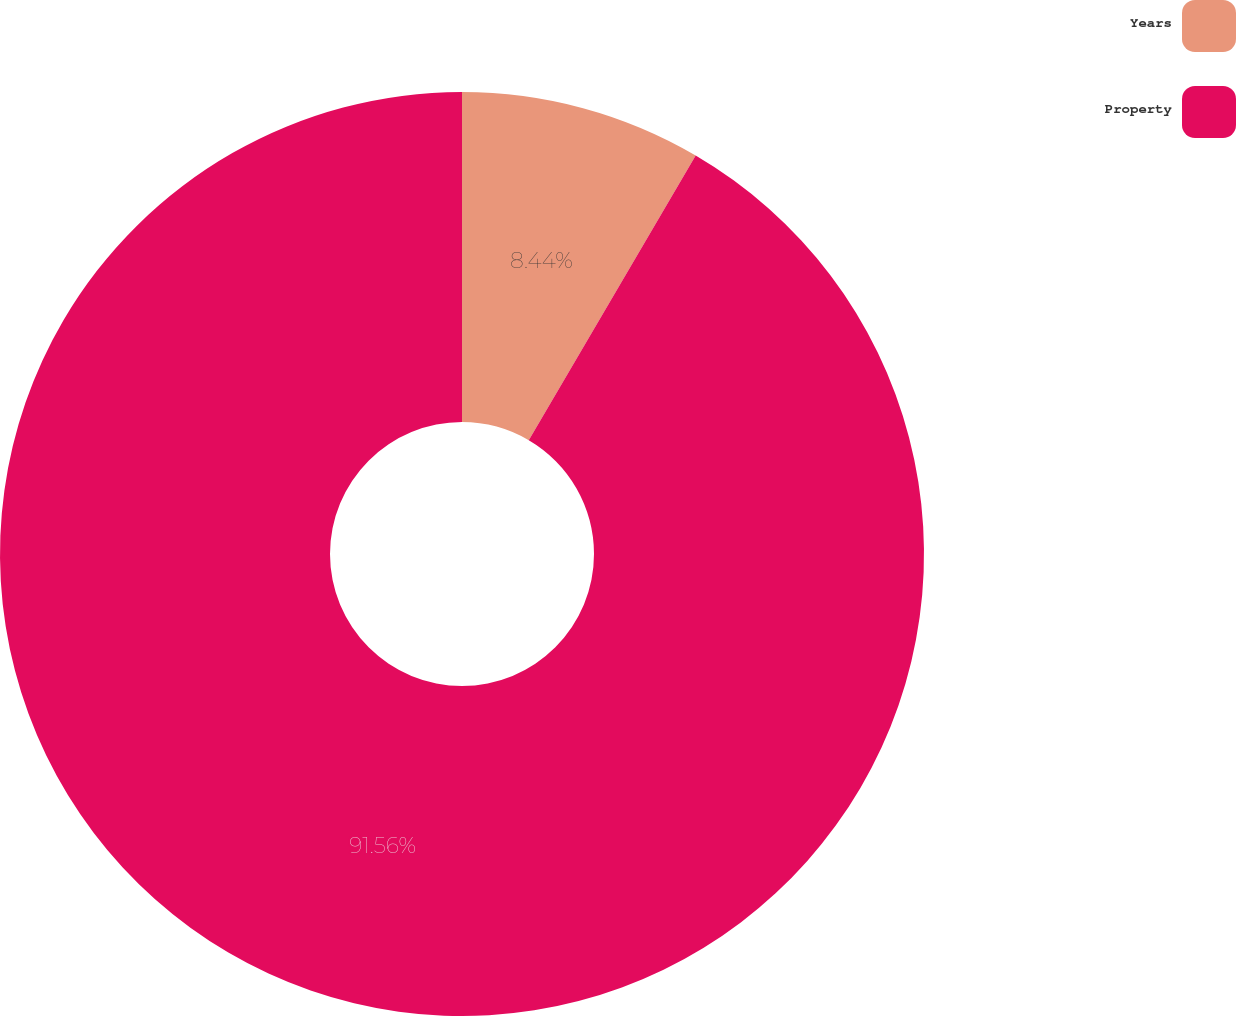Convert chart to OTSL. <chart><loc_0><loc_0><loc_500><loc_500><pie_chart><fcel>Years<fcel>Property<nl><fcel>8.44%<fcel>91.56%<nl></chart> 